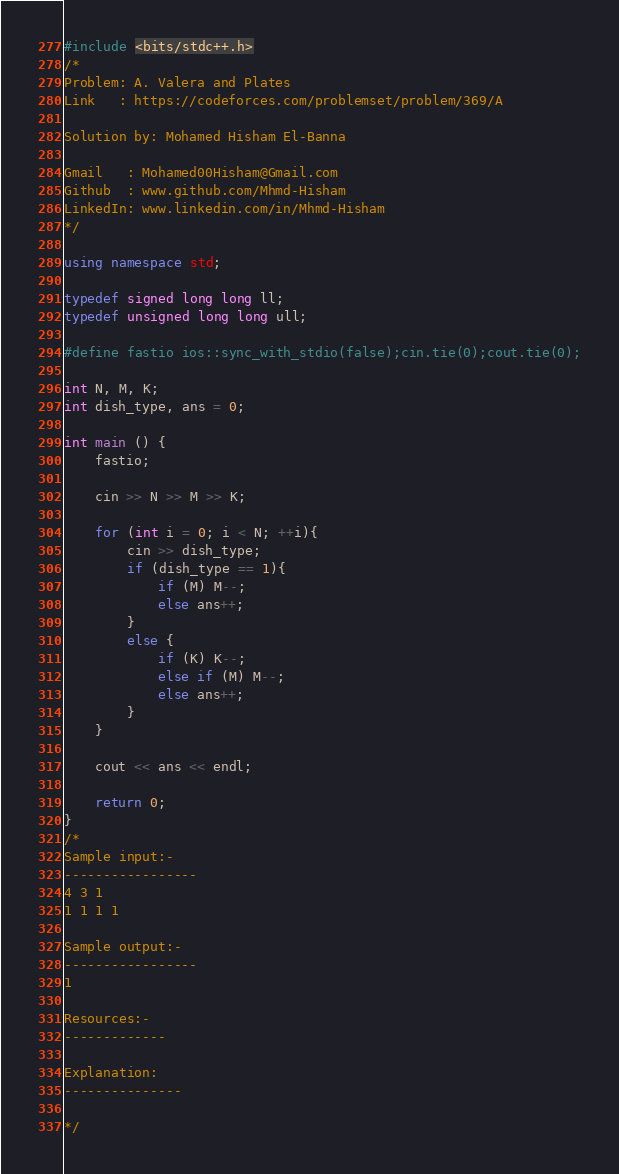<code> <loc_0><loc_0><loc_500><loc_500><_C++_>#include <bits/stdc++.h>
/*
Problem: A. Valera and Plates
Link   : https://codeforces.com/problemset/problem/369/A

Solution by: Mohamed Hisham El-Banna

Gmail   : Mohamed00Hisham@Gmail.com
Github  : www.github.com/Mhmd-Hisham
LinkedIn: www.linkedin.com/in/Mhmd-Hisham
*/

using namespace std;

typedef signed long long ll;
typedef unsigned long long ull;

#define fastio ios::sync_with_stdio(false);cin.tie(0);cout.tie(0);

int N, M, K;
int dish_type, ans = 0;

int main () {
    fastio;
    
    cin >> N >> M >> K;

    for (int i = 0; i < N; ++i){
        cin >> dish_type;
        if (dish_type == 1){ 
            if (M) M--;
            else ans++;
        }
        else {
            if (K) K--;
            else if (M) M--;
            else ans++;
        }
    }
    
    cout << ans << endl;
    
    return 0;
}
/*
Sample input:-
-----------------
4 3 1
1 1 1 1

Sample output:-
-----------------
1

Resources:-
-------------

Explanation:
---------------

*/
</code> 